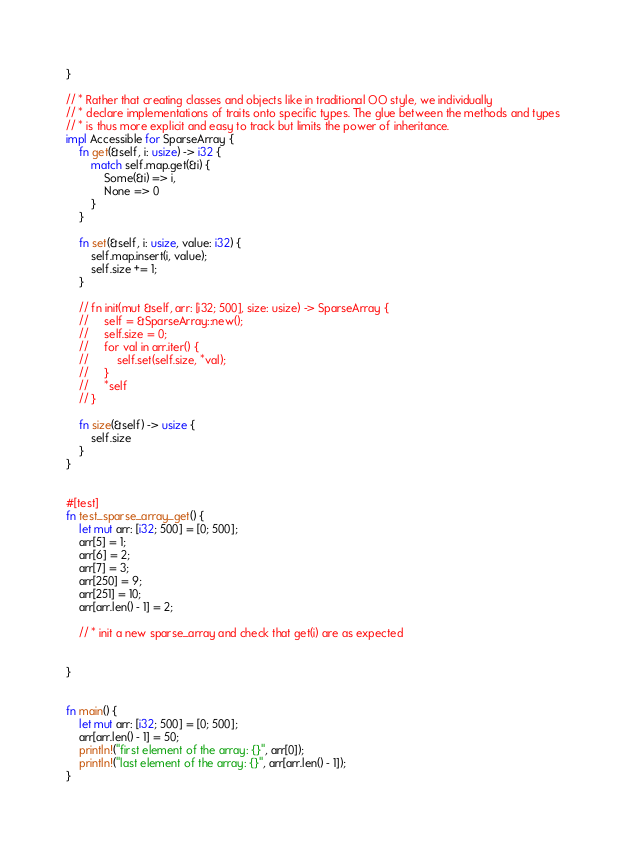<code> <loc_0><loc_0><loc_500><loc_500><_Rust_>}

// * Rather that creating classes and objects like in traditional OO style, we individually
// * declare implementations of traits onto specific types. The glue between the methods and types
// * is thus more explicit and easy to track but limits the power of inheritance.
impl Accessible for SparseArray {
    fn get(&self, i: usize) -> i32 {
        match self.map.get(&i) {
            Some(&i) => i,
            None => 0
        }
    }

    fn set(&self, i: usize, value: i32) {
        self.map.insert(i, value);
        self.size += 1;
    }

    // fn init(mut &self, arr: [i32; 500], size: usize) -> SparseArray {
    //     self = &SparseArray::new();
    //     self.size = 0;
    //     for val in arr.iter() {
    //         self.set(self.size, *val);
    //     }
    //     *self
    // }

    fn size(&self) -> usize {
        self.size
    }
}


#[test]
fn test_sparse_array_get() {
    let mut arr: [i32; 500] = [0; 500];
    arr[5] = 1;
    arr[6] = 2;
    arr[7] = 3;
    arr[250] = 9;
    arr[251] = 10;
    arr[arr.len() - 1] = 2;

    // * init a new sparse_array and check that get(i) are as expected


}


fn main() {
    let mut arr: [i32; 500] = [0; 500];
    arr[arr.len() - 1] = 50;
    println!("first element of the array: {}", arr[0]);
    println!("last element of the array: {}", arr[arr.len() - 1]);
}
</code> 